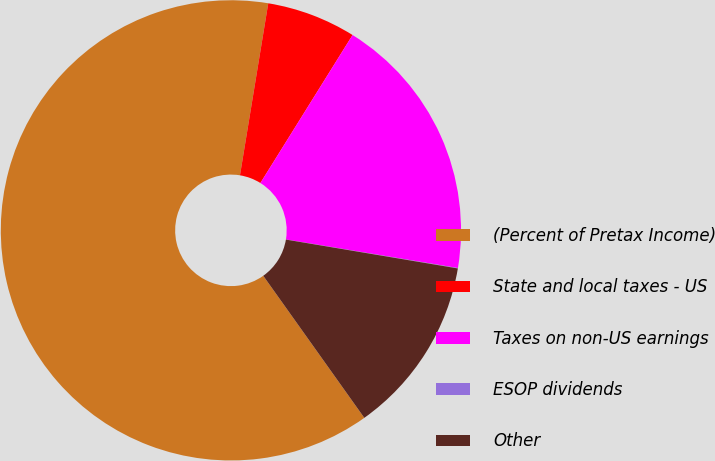Convert chart. <chart><loc_0><loc_0><loc_500><loc_500><pie_chart><fcel>(Percent of Pretax Income)<fcel>State and local taxes - US<fcel>Taxes on non-US earnings<fcel>ESOP dividends<fcel>Other<nl><fcel>62.43%<fcel>6.27%<fcel>18.75%<fcel>0.03%<fcel>12.51%<nl></chart> 